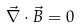<formula> <loc_0><loc_0><loc_500><loc_500>\vec { \nabla } \cdot \vec { B } = 0</formula> 